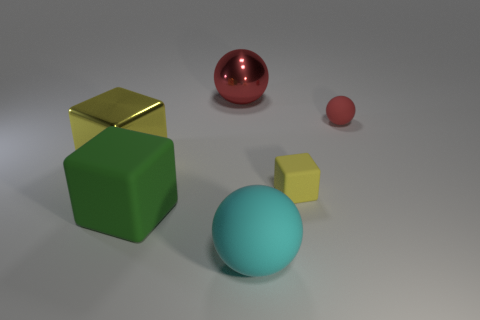Add 2 big objects. How many objects exist? 8 Subtract all gray blocks. Subtract all tiny rubber blocks. How many objects are left? 5 Add 6 small yellow matte objects. How many small yellow matte objects are left? 7 Add 5 red metallic blocks. How many red metallic blocks exist? 5 Subtract 0 red cylinders. How many objects are left? 6 